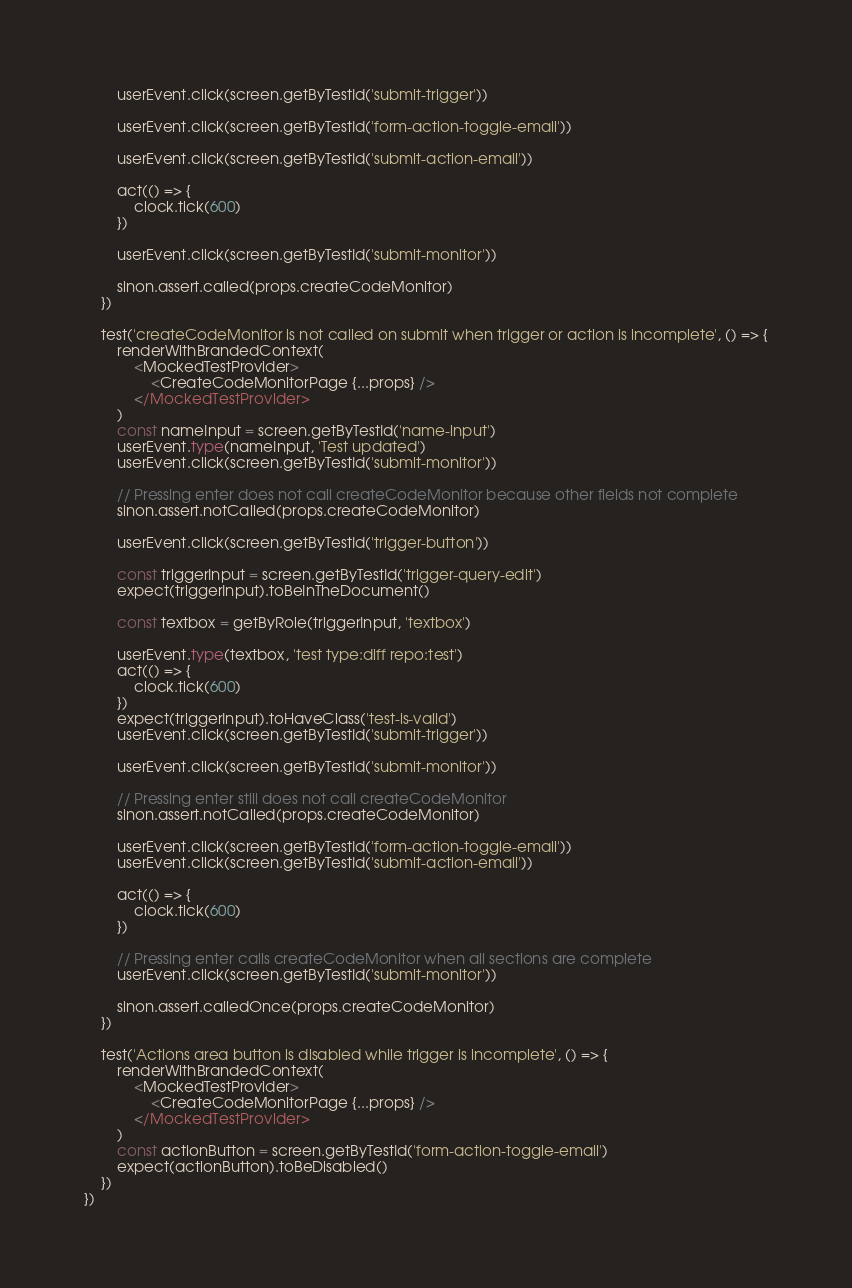<code> <loc_0><loc_0><loc_500><loc_500><_TypeScript_>
        userEvent.click(screen.getByTestId('submit-trigger'))

        userEvent.click(screen.getByTestId('form-action-toggle-email'))

        userEvent.click(screen.getByTestId('submit-action-email'))

        act(() => {
            clock.tick(600)
        })

        userEvent.click(screen.getByTestId('submit-monitor'))

        sinon.assert.called(props.createCodeMonitor)
    })

    test('createCodeMonitor is not called on submit when trigger or action is incomplete', () => {
        renderWithBrandedContext(
            <MockedTestProvider>
                <CreateCodeMonitorPage {...props} />
            </MockedTestProvider>
        )
        const nameInput = screen.getByTestId('name-input')
        userEvent.type(nameInput, 'Test updated')
        userEvent.click(screen.getByTestId('submit-monitor'))

        // Pressing enter does not call createCodeMonitor because other fields not complete
        sinon.assert.notCalled(props.createCodeMonitor)

        userEvent.click(screen.getByTestId('trigger-button'))

        const triggerInput = screen.getByTestId('trigger-query-edit')
        expect(triggerInput).toBeInTheDocument()

        const textbox = getByRole(triggerInput, 'textbox')

        userEvent.type(textbox, 'test type:diff repo:test')
        act(() => {
            clock.tick(600)
        })
        expect(triggerInput).toHaveClass('test-is-valid')
        userEvent.click(screen.getByTestId('submit-trigger'))

        userEvent.click(screen.getByTestId('submit-monitor'))

        // Pressing enter still does not call createCodeMonitor
        sinon.assert.notCalled(props.createCodeMonitor)

        userEvent.click(screen.getByTestId('form-action-toggle-email'))
        userEvent.click(screen.getByTestId('submit-action-email'))

        act(() => {
            clock.tick(600)
        })

        // Pressing enter calls createCodeMonitor when all sections are complete
        userEvent.click(screen.getByTestId('submit-monitor'))

        sinon.assert.calledOnce(props.createCodeMonitor)
    })

    test('Actions area button is disabled while trigger is incomplete', () => {
        renderWithBrandedContext(
            <MockedTestProvider>
                <CreateCodeMonitorPage {...props} />
            </MockedTestProvider>
        )
        const actionButton = screen.getByTestId('form-action-toggle-email')
        expect(actionButton).toBeDisabled()
    })
})
</code> 